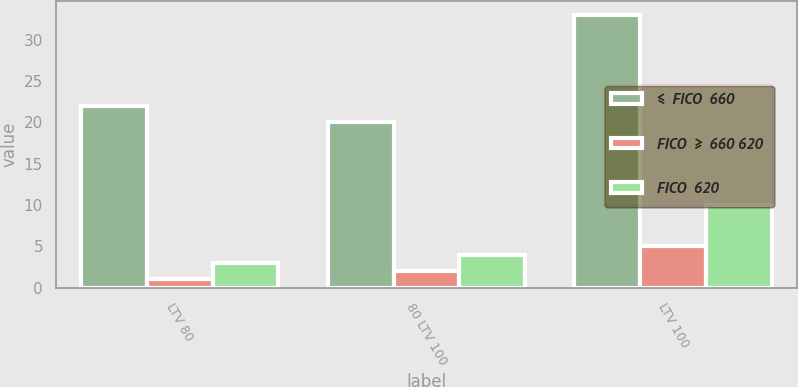<chart> <loc_0><loc_0><loc_500><loc_500><stacked_bar_chart><ecel><fcel>LTV 80<fcel>80 LTV 100<fcel>LTV 100<nl><fcel>≤  FICO  660<fcel>22<fcel>20<fcel>33<nl><fcel>FICO  ≥  660 620<fcel>1<fcel>2<fcel>5<nl><fcel>FICO  620<fcel>3<fcel>4<fcel>10<nl></chart> 